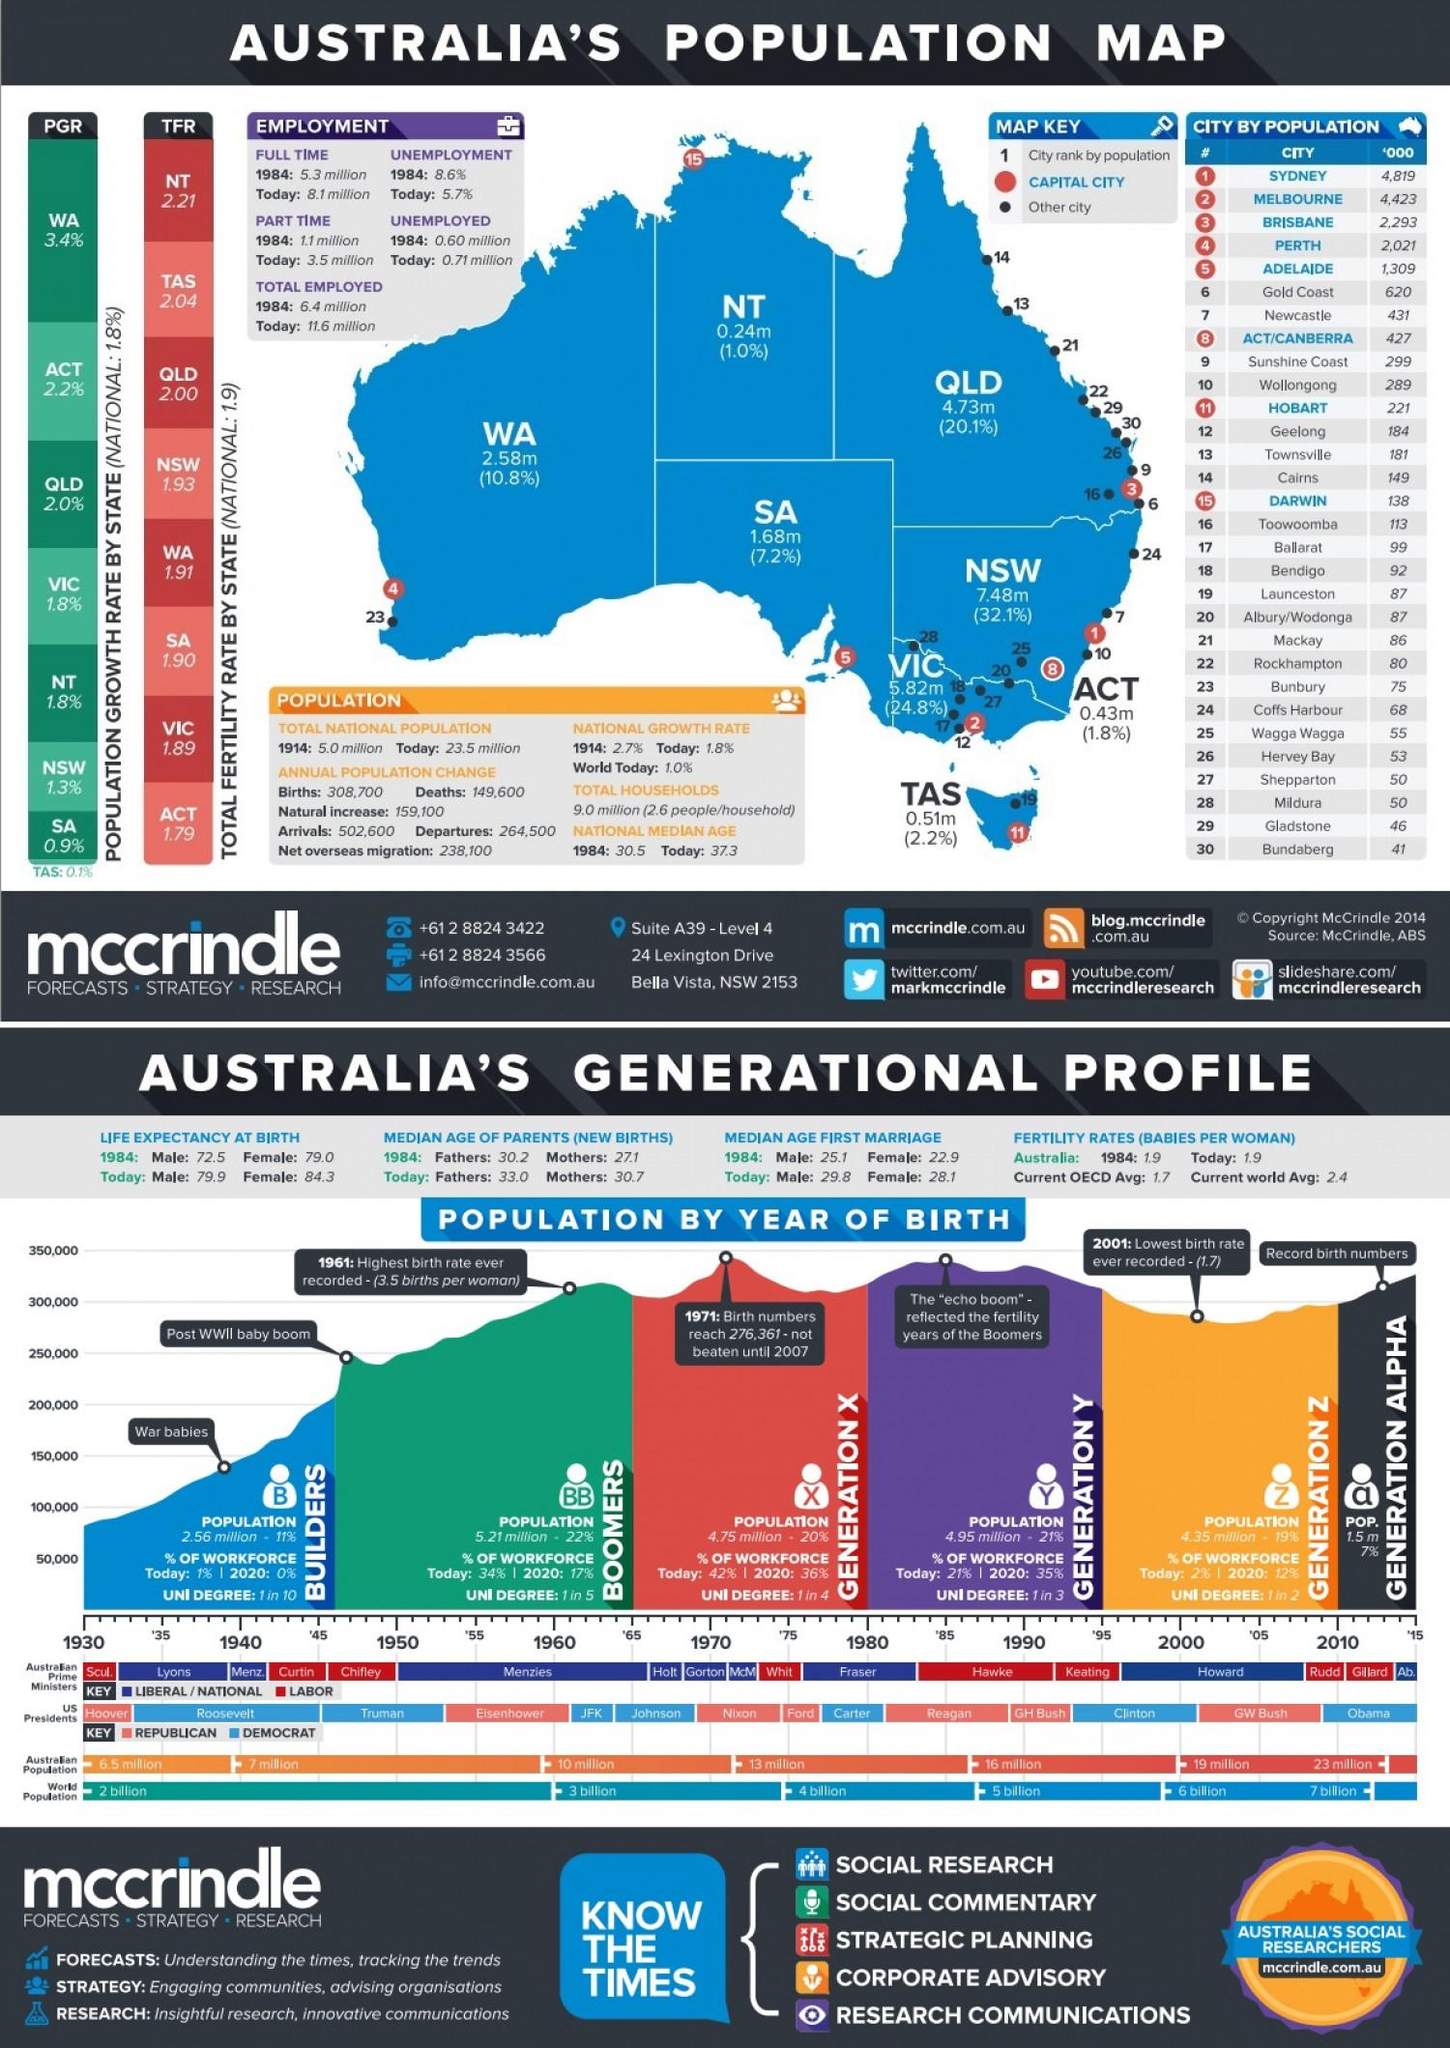Outline some significant characteristics in this image. As of 1984, the part-time employed population of Australia was approximately 1.1 million people. The national population growth rate of Australia in the year 1914 was 2.7%. The population growth rate in Victoria is 1.8%. Hobart is the capital city of Tasmania, which is located in Australia. The city with the highest population in Australia is Sydney. 